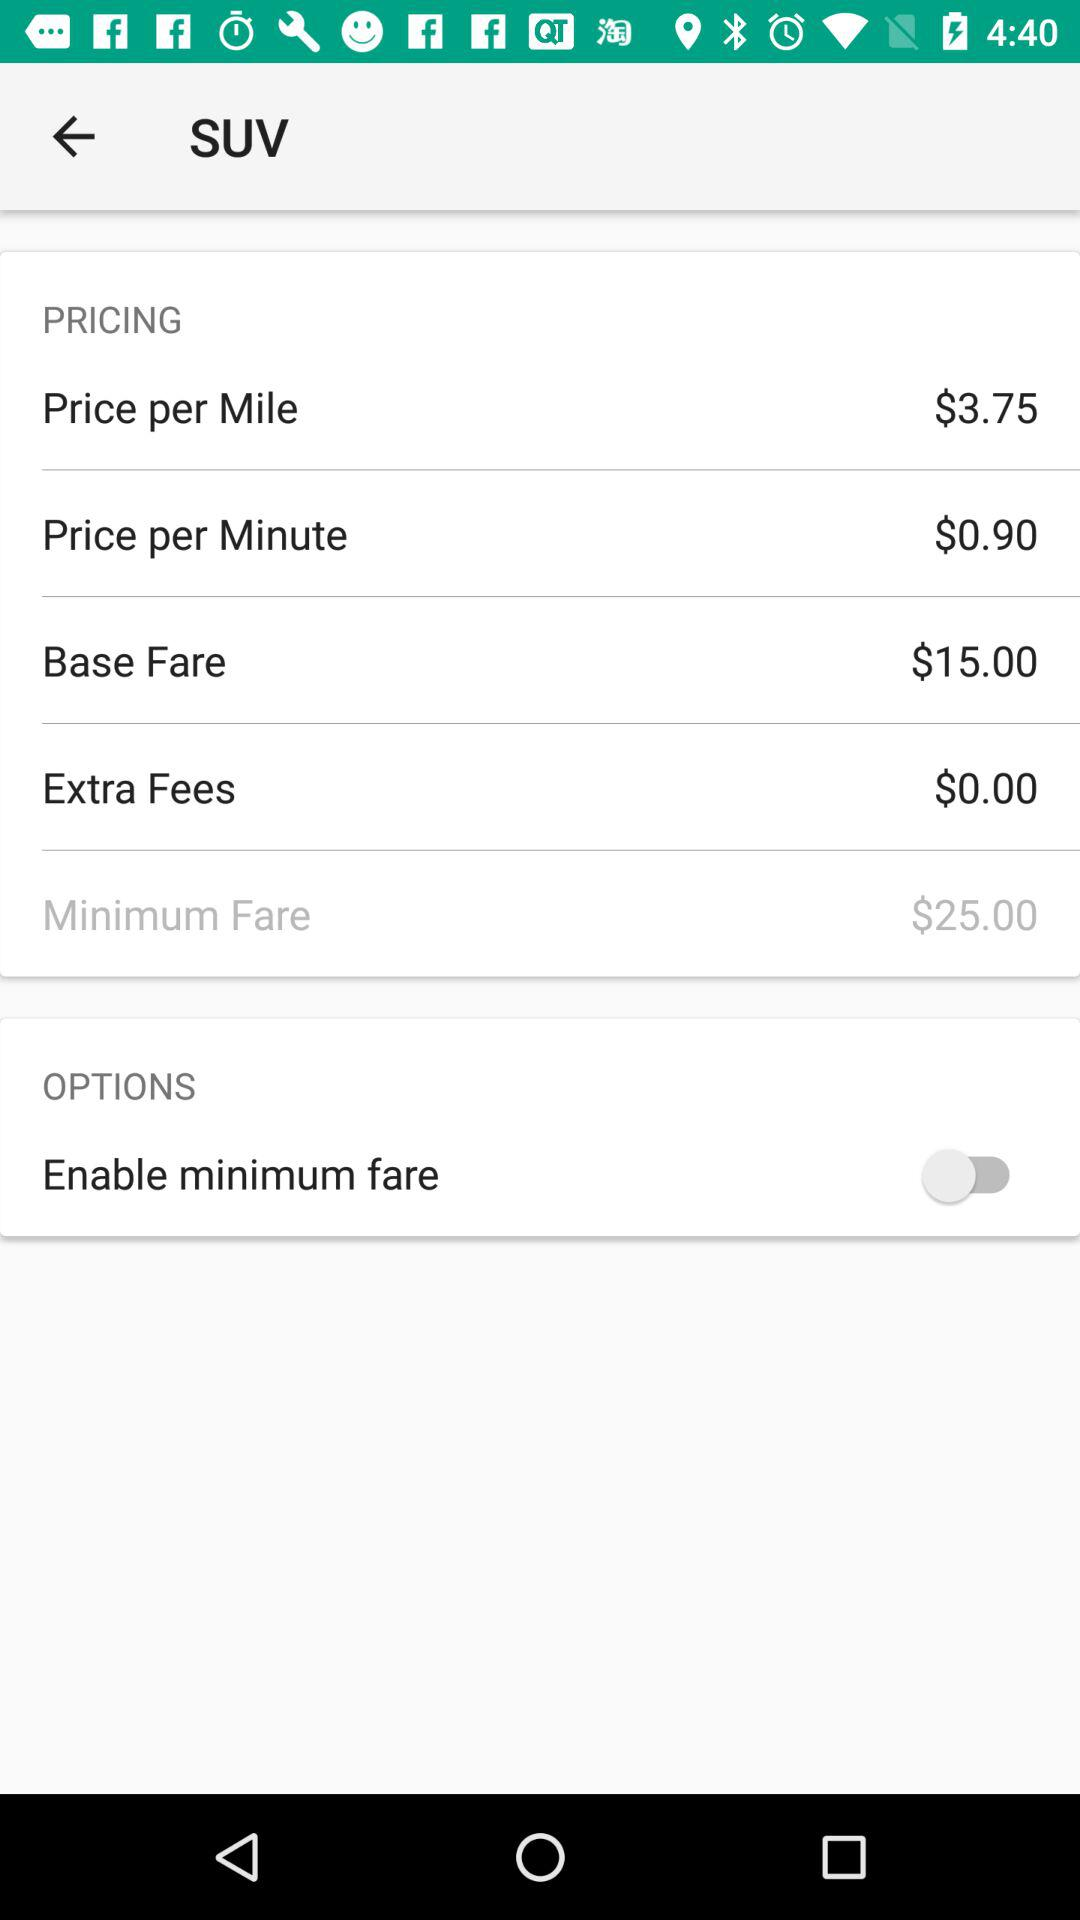What is the price per mile? The price per mile is $3.75. 